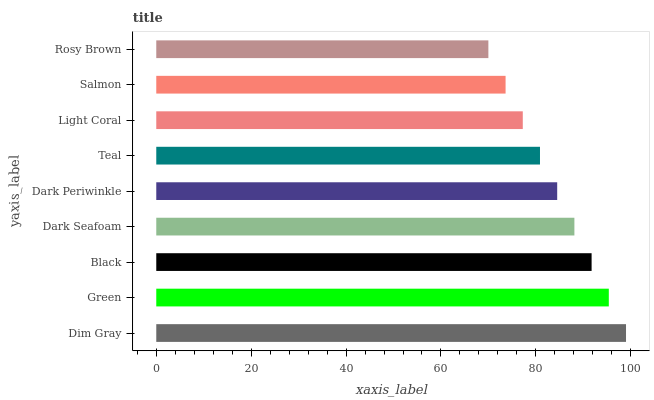Is Rosy Brown the minimum?
Answer yes or no. Yes. Is Dim Gray the maximum?
Answer yes or no. Yes. Is Green the minimum?
Answer yes or no. No. Is Green the maximum?
Answer yes or no. No. Is Dim Gray greater than Green?
Answer yes or no. Yes. Is Green less than Dim Gray?
Answer yes or no. Yes. Is Green greater than Dim Gray?
Answer yes or no. No. Is Dim Gray less than Green?
Answer yes or no. No. Is Dark Periwinkle the high median?
Answer yes or no. Yes. Is Dark Periwinkle the low median?
Answer yes or no. Yes. Is Green the high median?
Answer yes or no. No. Is Black the low median?
Answer yes or no. No. 